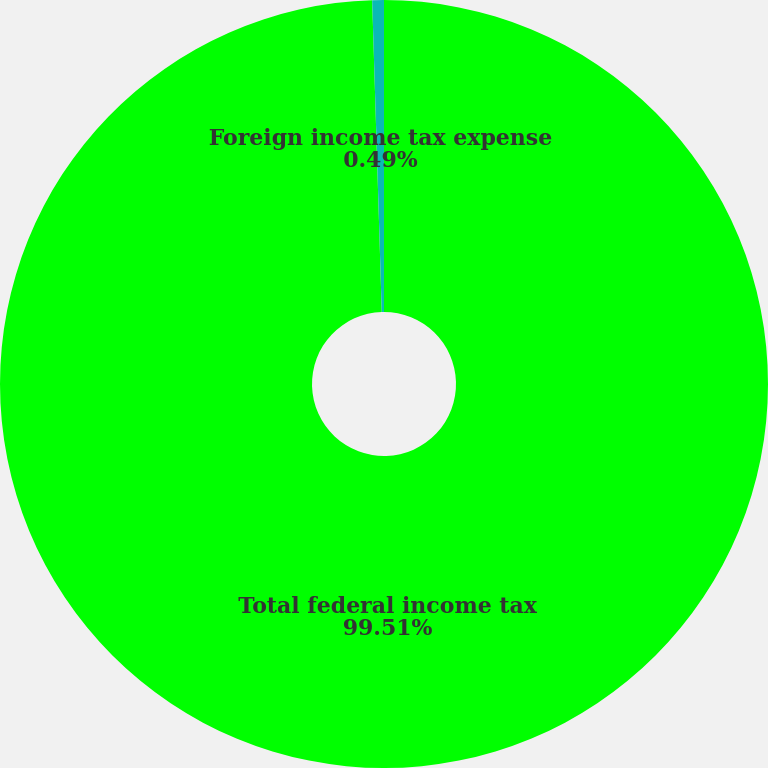<chart> <loc_0><loc_0><loc_500><loc_500><pie_chart><fcel>Total federal income tax<fcel>Foreign income tax expense<nl><fcel>99.51%<fcel>0.49%<nl></chart> 